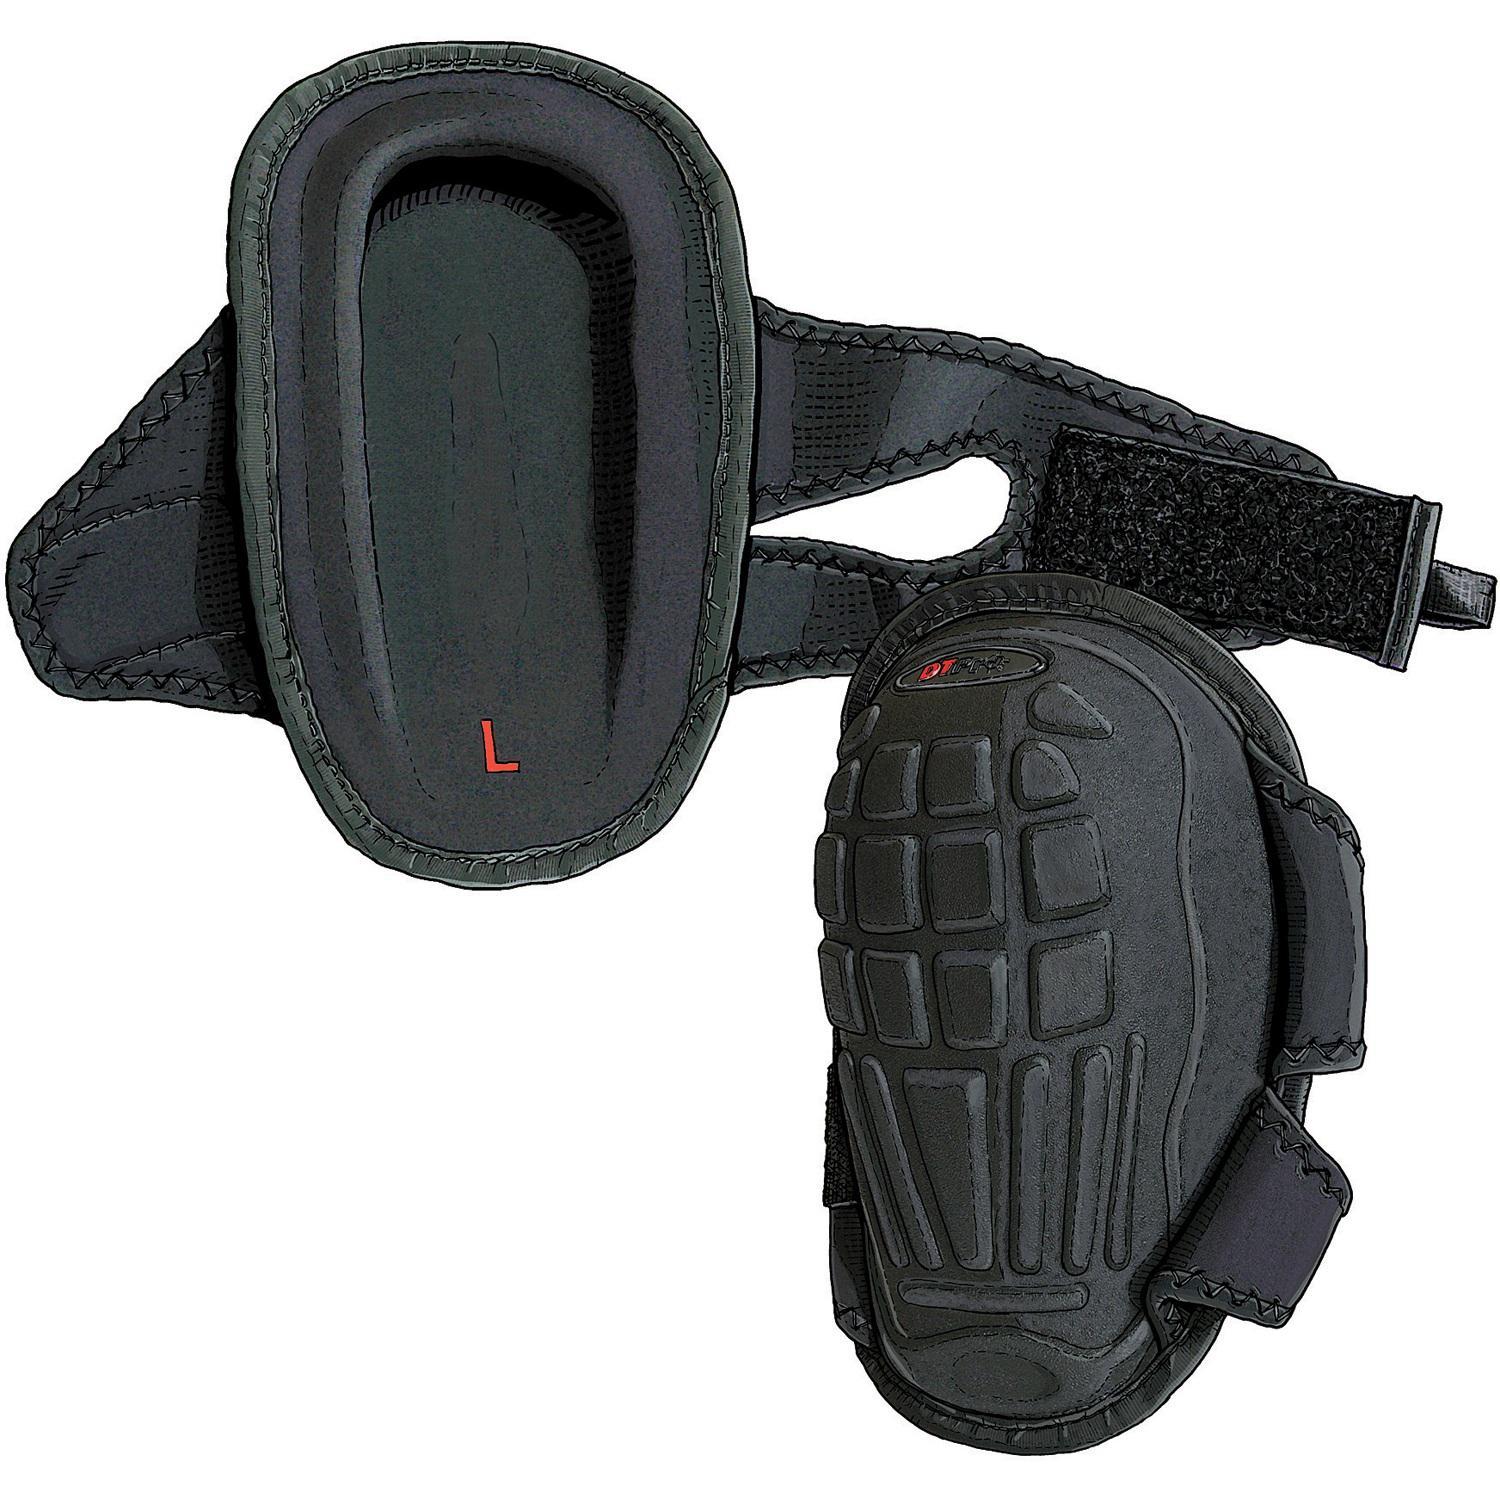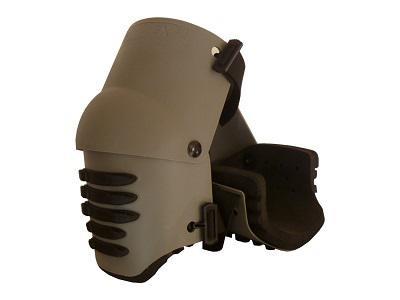The first image is the image on the left, the second image is the image on the right. Analyze the images presented: Is the assertion "An image shows a pair of black knee pads with yellow trim on the front." valid? Answer yes or no. No. The first image is the image on the left, the second image is the image on the right. Analyze the images presented: Is the assertion "At least one of the sets of knee pads is only yellow and grey." valid? Answer yes or no. No. 